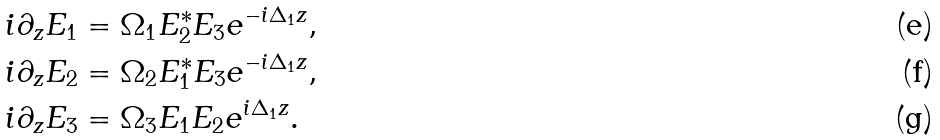<formula> <loc_0><loc_0><loc_500><loc_500>i \partial _ { z } E _ { 1 } & = \Omega _ { 1 } E _ { 2 } ^ { \ast } E _ { 3 } e ^ { - i \Delta _ { 1 } z } , \\ i \partial _ { z } E _ { 2 } & = \Omega _ { 2 } E _ { 1 } ^ { \ast } E _ { 3 } e ^ { - i \Delta _ { 1 } z } , \\ i \partial _ { z } E _ { 3 } & = \Omega _ { 3 } E _ { 1 } E _ { 2 } e ^ { i \Delta _ { 1 } z } .</formula> 